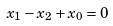Convert formula to latex. <formula><loc_0><loc_0><loc_500><loc_500>x _ { 1 } - x _ { 2 } + x _ { 0 } = 0</formula> 